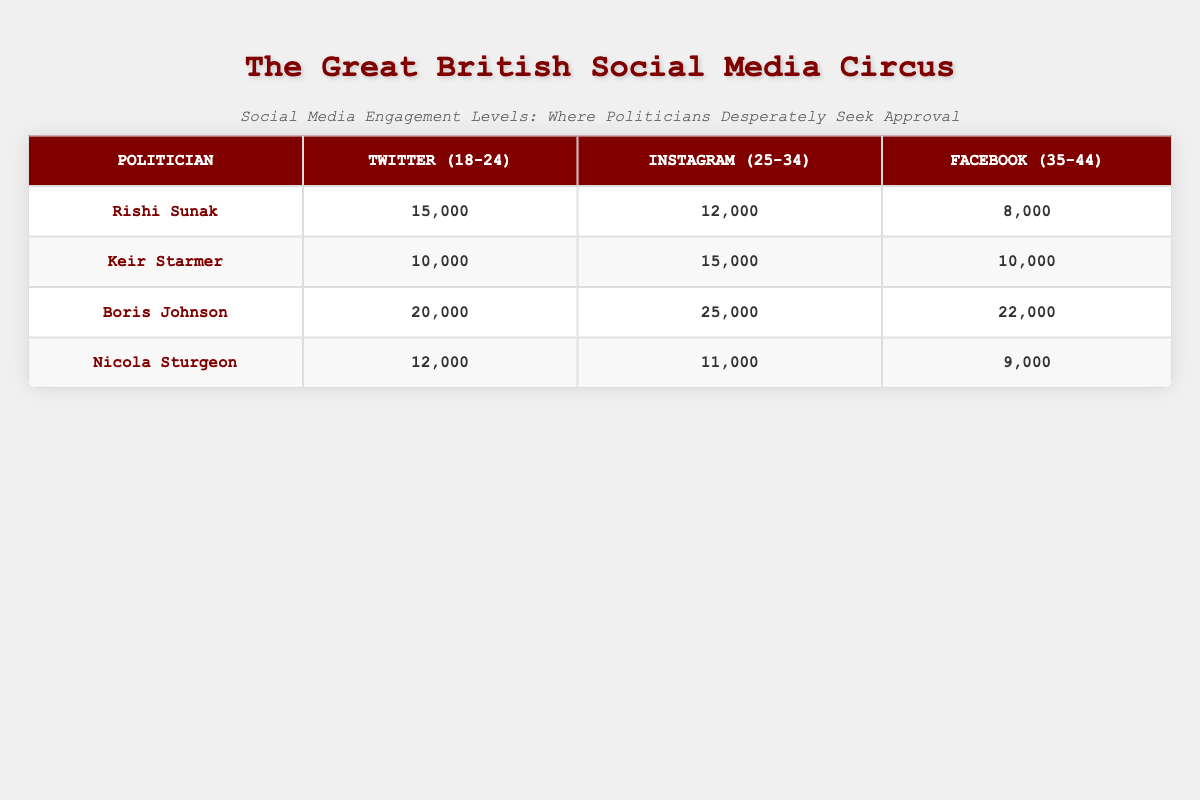What is the engagement level for Rishi Sunak on Twitter for the 18-24 demographic? According to the table, Rishi Sunak's engagement level on Twitter for the 18-24 age group is explicitly listed as 15,000.
Answer: 15,000 Which politician has the highest engagement level on Instagram for the 25-34 demographic? The table shows that Boris Johnson has the highest engagement level on Instagram for the 25-34 age group with a total of 25,000, compared to the others listed.
Answer: Boris Johnson What is the total engagement level for Keir Starmer across all platforms? To find the total engagement level for Keir Starmer, I add the engagement levels from Twitter (10,000), Instagram (15,000), and Facebook (10,000). This gives a total of 10,000 + 15,000 + 10,000 = 35,000.
Answer: 35,000 Is it true that Nicola Sturgeon has a higher engagement level on Instagram than Rishi Sunak? Looking at the engagement levels, Nicola Sturgeon has an Instagram engagement level of 11,000, while Rishi Sunak has 12,000. Since 11,000 is not higher than 12,000, the statement is false.
Answer: No What is the difference between Boris Johnson's engagement level on Facebook and the engagement level of Rishi Sunak on Twitter? First, I identify Boris Johnson's engagement on Facebook as 22,000 and Rishi Sunak's engagement on Twitter as 15,000. To find the difference, I subtract 15,000 from 22,000 which gives 22,000 - 15,000 = 7,000.
Answer: 7,000 Which platform had the lowest overall engagement levels across the four politicians for the 35-44 demographic? Looking at the engagement levels for the 35-44 demographic across the platforms, Rishi Sunak has 8,000, Keir Starmer has 10,000, Boris Johnson has 22,000, and Nicola Sturgeon has 9,000. The lowest is Rishi Sunak's 8,000 on Facebook.
Answer: Facebook What is the average engagement level for all politicians on Twitter? I find the engagement levels for Twitter: Rishi Sunak 15,000, Keir Starmer 10,000, Boris Johnson 20,000, and Nicola Sturgeon 12,000. I sum these values (15,000 + 10,000 + 20,000 + 12,000 = 57,000) and divide by 4 (57,000/4 = 14,250) to find the average.
Answer: 14,250 Which politician has the highest total engagement in the 25-34 demographic across all platforms? I check each politician's engagement in that demographic: Rishi Sunak has 12,000, Keir Starmer has 15,000, Boris Johnson has 25,000, and Nicola Sturgeon has 11,000. Boris Johnson's 25,000 is the highest.
Answer: Boris Johnson 